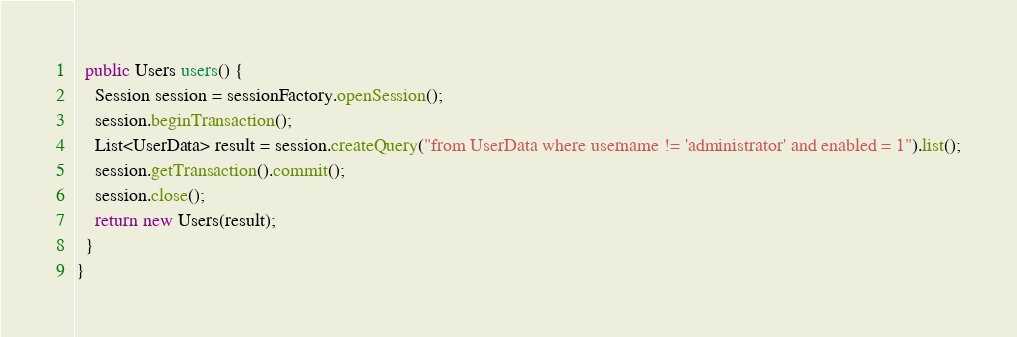Convert code to text. <code><loc_0><loc_0><loc_500><loc_500><_Java_>  public Users users() {
    Session session = sessionFactory.openSession();
    session.beginTransaction();
    List<UserData> result = session.createQuery("from UserData where username != 'administrator' and enabled = 1").list();
    session.getTransaction().commit();
    session.close();
    return new Users(result);
  }
}
</code> 